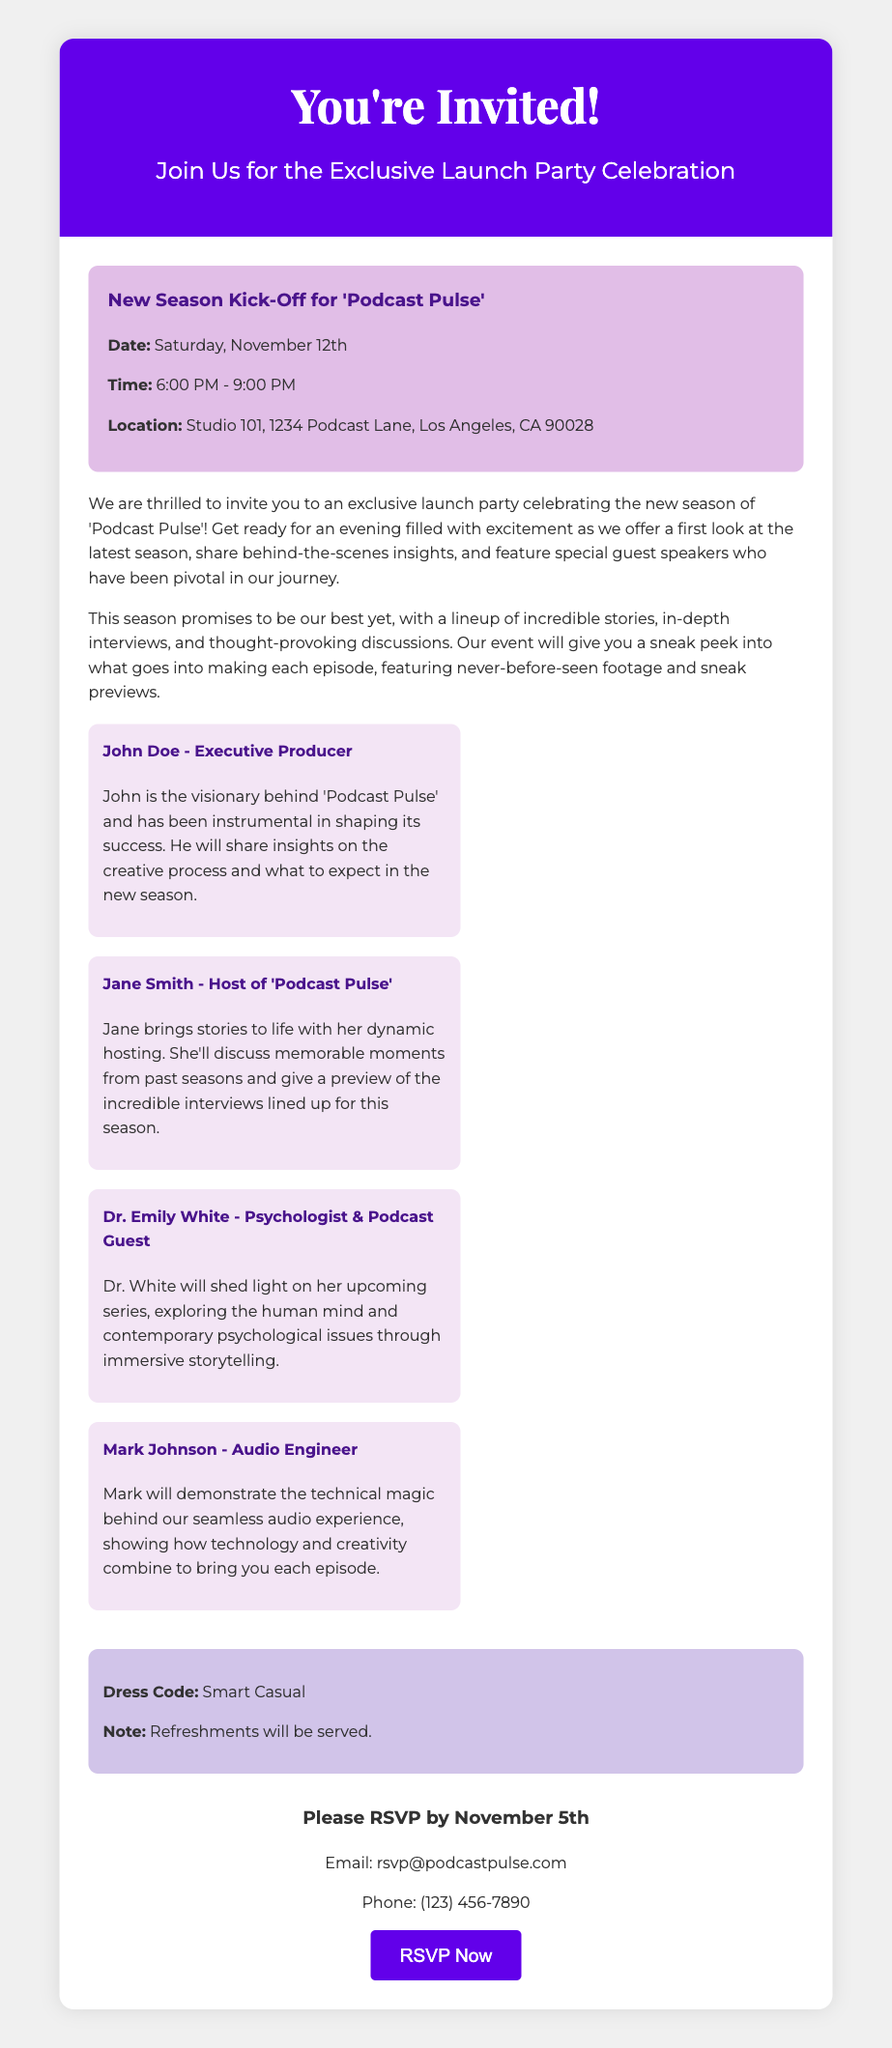what is the date of the launch party? The date of the launch party is mentioned in the event details section, which states it will be held on Saturday, November 12th.
Answer: Saturday, November 12th what time does the launch party start? The starting time of the launch party is listed in the event details as 6:00 PM.
Answer: 6:00 PM who is the host of 'Podcast Pulse'? The document specifies that Jane Smith is the host of 'Podcast Pulse'.
Answer: Jane Smith what is the dress code for the event? The dress code is stated in the additional info section, which specifies that guests should dress in smart casual attire.
Answer: Smart Casual how many guest speakers are listed? The document lists four guest speakers in the guests section, indicating the number of speakers featured at the event.
Answer: Four what is the main focus of the event? The purpose of the event is highlighted in the description section, whereby it aims to celebrate the new season and share insights.
Answer: Celebrate the new season by when should attendees RSVP? The RSVP deadline is mentioned in the RSVP section of the document, specifically stating that responses must be received by November 5th.
Answer: November 5th where is the launch party located? The location of the launch party is provided in the event details, showing it will take place at Studio 101, 1234 Podcast Lane, Los Angeles, CA 90028.
Answer: Studio 101, 1234 Podcast Lane, Los Angeles, CA 90028 what will be served at the event? The additional info section mentions that refreshments will be served during the event, indicating what attendees can expect.
Answer: Refreshments 